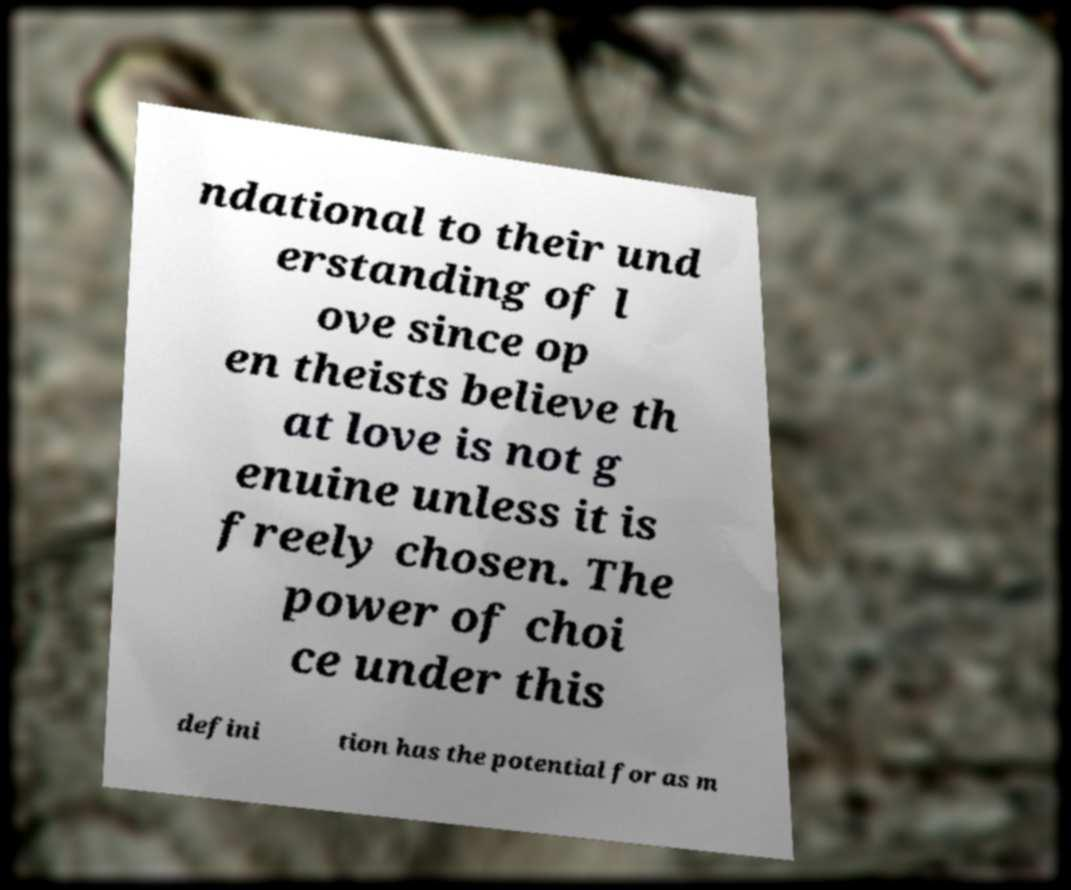Can you read and provide the text displayed in the image?This photo seems to have some interesting text. Can you extract and type it out for me? ndational to their und erstanding of l ove since op en theists believe th at love is not g enuine unless it is freely chosen. The power of choi ce under this defini tion has the potential for as m 